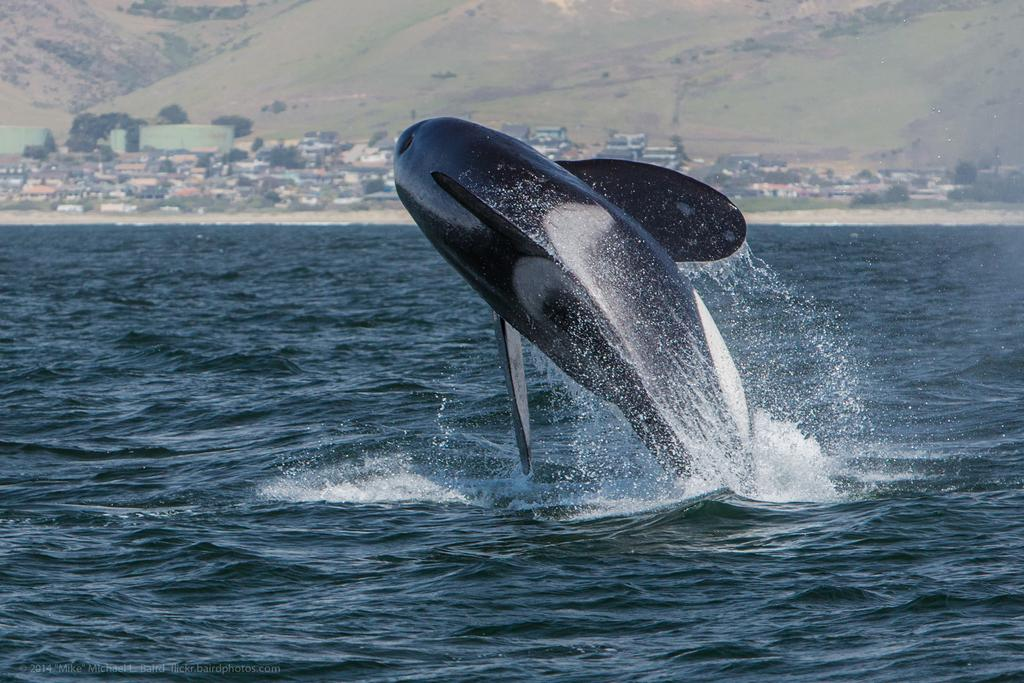What is the primary element in the image? The image consists of water. What animal can be seen in the middle of the image? There is a dolphin in the middle of the image. What structures are present in the middle of the image? There are houses in the middle of the image. What type of vegetation is visible in the middle of the image? There are trees in the middle of the image. What geographical feature is located at the top of the image? There is a mountain-like feature at the top of the image. What type of key is being used to unlock the door of the house in the image? There is no door or key present in the image; it consists of water with a dolphin, trees, and a mountain-like feature. 